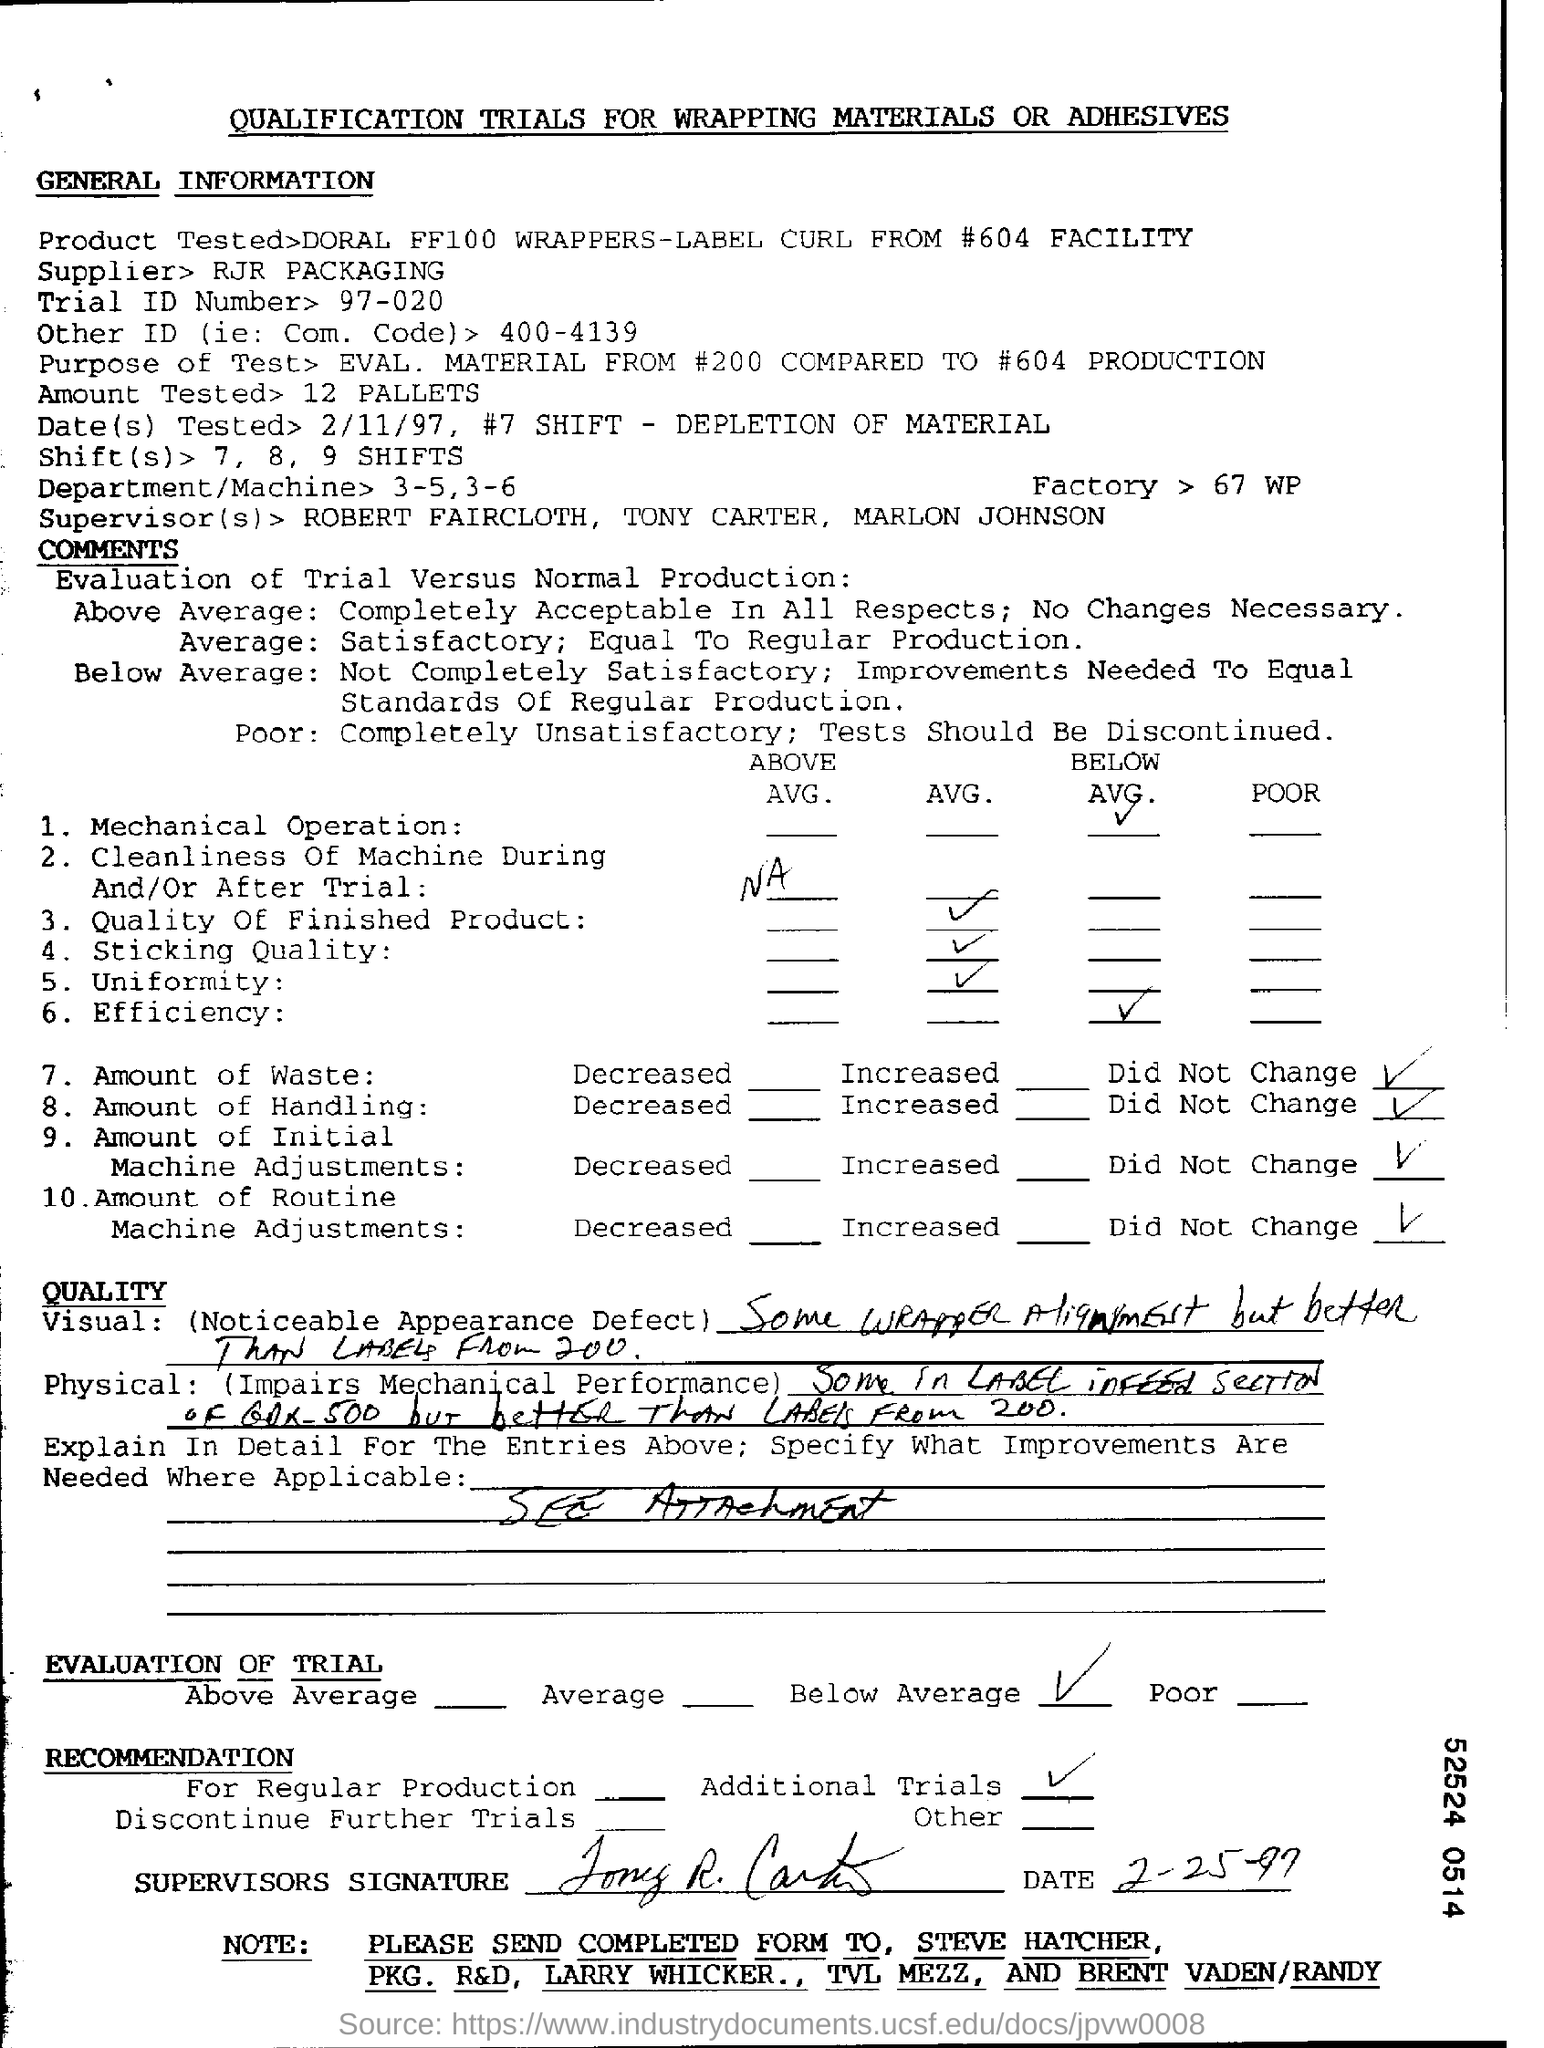What is the Trial ID Number?
Offer a terse response. 97-020. What is the purpose of test?
Your answer should be very brief. EVAL. MATERIAL FROM #200 COMPARED TO #604 PRODUCTION. 